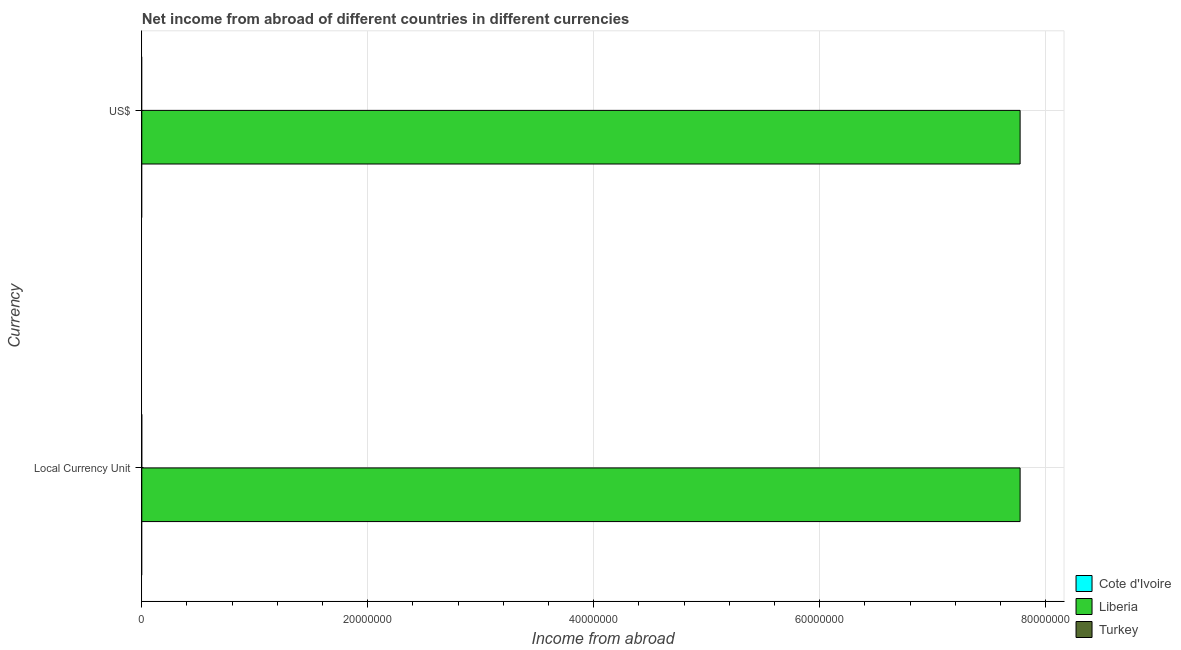How many different coloured bars are there?
Your answer should be compact. 1. Are the number of bars per tick equal to the number of legend labels?
Your answer should be very brief. No. What is the label of the 1st group of bars from the top?
Provide a succinct answer. US$. What is the income from abroad in us$ in Liberia?
Ensure brevity in your answer.  7.77e+07. Across all countries, what is the maximum income from abroad in constant 2005 us$?
Ensure brevity in your answer.  7.77e+07. Across all countries, what is the minimum income from abroad in constant 2005 us$?
Your answer should be compact. 0. In which country was the income from abroad in us$ maximum?
Provide a short and direct response. Liberia. What is the total income from abroad in us$ in the graph?
Give a very brief answer. 7.77e+07. What is the difference between the income from abroad in us$ in Cote d'Ivoire and the income from abroad in constant 2005 us$ in Turkey?
Your answer should be compact. 0. What is the average income from abroad in us$ per country?
Make the answer very short. 2.59e+07. What is the difference between the income from abroad in constant 2005 us$ and income from abroad in us$ in Liberia?
Your answer should be very brief. 0. Are all the bars in the graph horizontal?
Ensure brevity in your answer.  Yes. What is the difference between two consecutive major ticks on the X-axis?
Keep it short and to the point. 2.00e+07. Does the graph contain any zero values?
Your response must be concise. Yes. Does the graph contain grids?
Make the answer very short. Yes. Where does the legend appear in the graph?
Make the answer very short. Bottom right. How many legend labels are there?
Offer a terse response. 3. How are the legend labels stacked?
Ensure brevity in your answer.  Vertical. What is the title of the graph?
Make the answer very short. Net income from abroad of different countries in different currencies. What is the label or title of the X-axis?
Offer a very short reply. Income from abroad. What is the label or title of the Y-axis?
Ensure brevity in your answer.  Currency. What is the Income from abroad in Cote d'Ivoire in Local Currency Unit?
Offer a very short reply. 0. What is the Income from abroad in Liberia in Local Currency Unit?
Keep it short and to the point. 7.77e+07. What is the Income from abroad of Cote d'Ivoire in US$?
Offer a terse response. 0. What is the Income from abroad of Liberia in US$?
Keep it short and to the point. 7.77e+07. Across all Currency, what is the maximum Income from abroad in Liberia?
Make the answer very short. 7.77e+07. Across all Currency, what is the minimum Income from abroad in Liberia?
Provide a short and direct response. 7.77e+07. What is the total Income from abroad in Liberia in the graph?
Offer a terse response. 1.55e+08. What is the average Income from abroad of Cote d'Ivoire per Currency?
Provide a short and direct response. 0. What is the average Income from abroad in Liberia per Currency?
Keep it short and to the point. 7.77e+07. What is the average Income from abroad of Turkey per Currency?
Make the answer very short. 0. What is the difference between the highest and the second highest Income from abroad of Liberia?
Offer a very short reply. 0. 